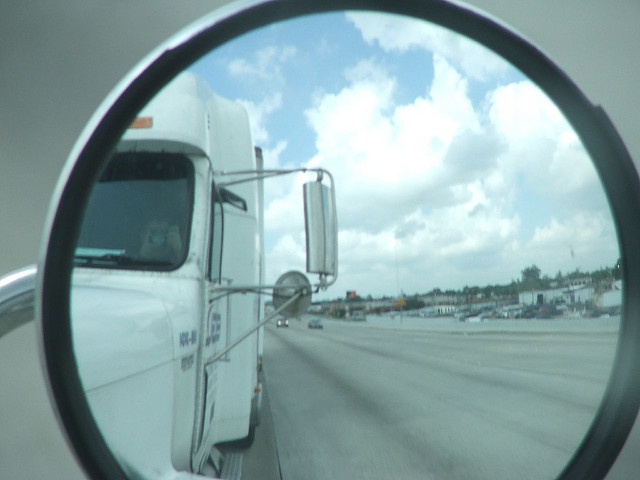Describe the objects in this image and their specific colors. I can see truck in gray, lightblue, and teal tones, people in gray, teal, black, and darkblue tones, and car in gray, teal, and purple tones in this image. 